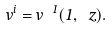Convert formula to latex. <formula><loc_0><loc_0><loc_500><loc_500>v ^ { i } = v ^ { \ 1 } ( 1 , \ z ) .</formula> 